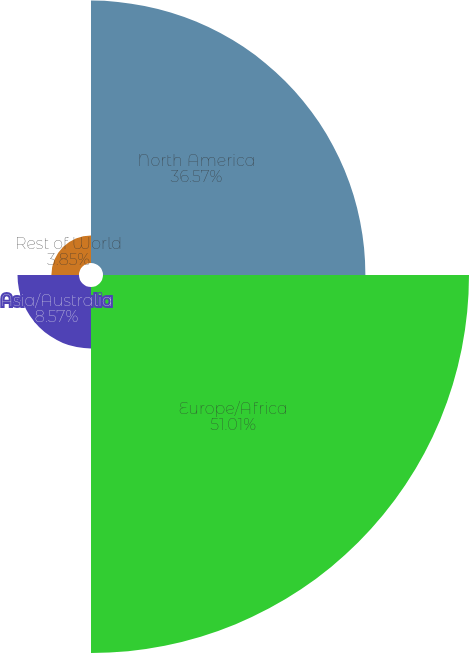<chart> <loc_0><loc_0><loc_500><loc_500><pie_chart><fcel>North America<fcel>Europe/Africa<fcel>Asia/Australia<fcel>Rest of World<nl><fcel>36.57%<fcel>51.01%<fcel>8.57%<fcel>3.85%<nl></chart> 